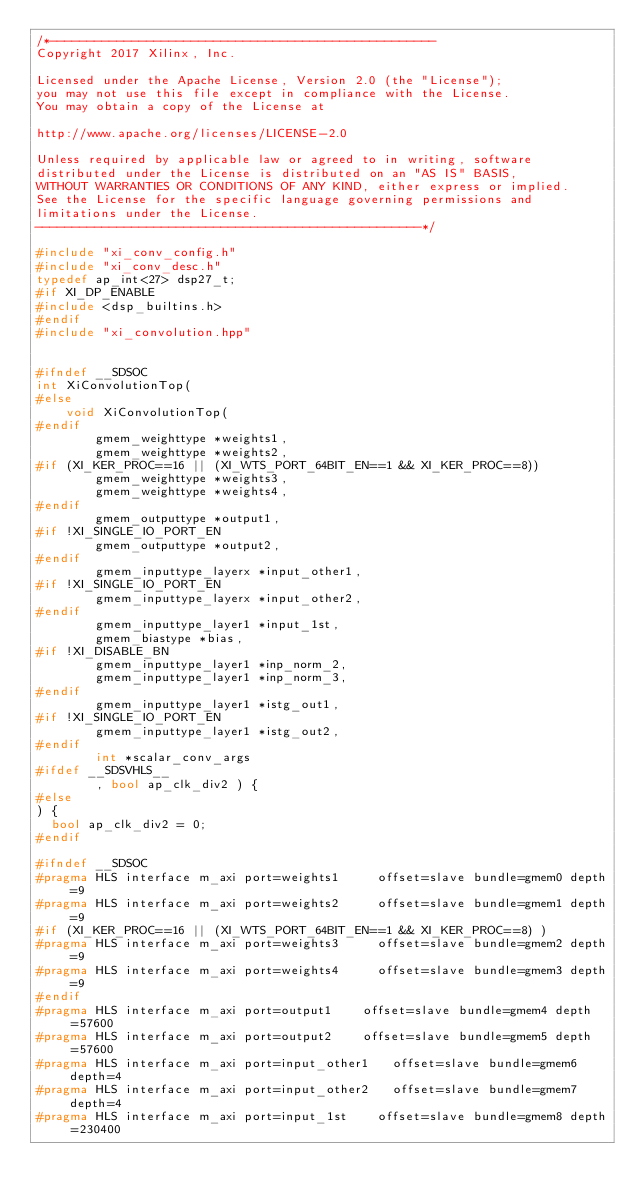Convert code to text. <code><loc_0><loc_0><loc_500><loc_500><_C++_>/*----------------------------------------------------
Copyright 2017 Xilinx, Inc.

Licensed under the Apache License, Version 2.0 (the "License");
you may not use this file except in compliance with the License.
You may obtain a copy of the License at

http://www.apache.org/licenses/LICENSE-2.0

Unless required by applicable law or agreed to in writing, software
distributed under the License is distributed on an "AS IS" BASIS,
WITHOUT WARRANTIES OR CONDITIONS OF ANY KIND, either express or implied.
See the License for the specific language governing permissions and
limitations under the License.
----------------------------------------------------*/

#include "xi_conv_config.h"
#include "xi_conv_desc.h"
typedef ap_int<27> dsp27_t;
#if XI_DP_ENABLE
#include <dsp_builtins.h>
#endif
#include "xi_convolution.hpp"


#ifndef __SDSOC
int XiConvolutionTop(
#else
		void XiConvolutionTop(
#endif
				gmem_weighttype *weights1,
				gmem_weighttype *weights2,
#if (XI_KER_PROC==16 || (XI_WTS_PORT_64BIT_EN==1 && XI_KER_PROC==8))
				gmem_weighttype *weights3,
				gmem_weighttype *weights4,
#endif
				gmem_outputtype *output1,
#if !XI_SINGLE_IO_PORT_EN
				gmem_outputtype *output2,
#endif
				gmem_inputtype_layerx *input_other1,
#if !XI_SINGLE_IO_PORT_EN
				gmem_inputtype_layerx *input_other2,
#endif
				gmem_inputtype_layer1 *input_1st,
				gmem_biastype *bias,
#if !XI_DISABLE_BN
				gmem_inputtype_layer1 *inp_norm_2,
				gmem_inputtype_layer1 *inp_norm_3,
#endif
				gmem_inputtype_layer1 *istg_out1,
#if !XI_SINGLE_IO_PORT_EN
				gmem_inputtype_layer1 *istg_out2,
#endif
				int *scalar_conv_args
#ifdef __SDSVHLS__
				, bool ap_clk_div2 ) {
#else
) {
	bool ap_clk_div2 = 0;
#endif

#ifndef __SDSOC
#pragma HLS interface m_axi port=weights1 		offset=slave bundle=gmem0 depth=9
#pragma HLS interface m_axi port=weights2 		offset=slave bundle=gmem1 depth=9
#if (XI_KER_PROC==16 || (XI_WTS_PORT_64BIT_EN==1 && XI_KER_PROC==8) )
#pragma HLS interface m_axi port=weights3 		offset=slave bundle=gmem2 depth=9
#pragma HLS interface m_axi port=weights4 		offset=slave bundle=gmem3 depth=9
#endif
#pragma HLS interface m_axi port=output1 		offset=slave bundle=gmem4 depth=57600
#pragma HLS interface m_axi port=output2 		offset=slave bundle=gmem5 depth=57600
#pragma HLS interface m_axi port=input_other1 	offset=slave bundle=gmem6 depth=4
#pragma HLS interface m_axi port=input_other2 	offset=slave bundle=gmem7 depth=4
#pragma HLS interface m_axi port=input_1st 		offset=slave bundle=gmem8 depth=230400</code> 